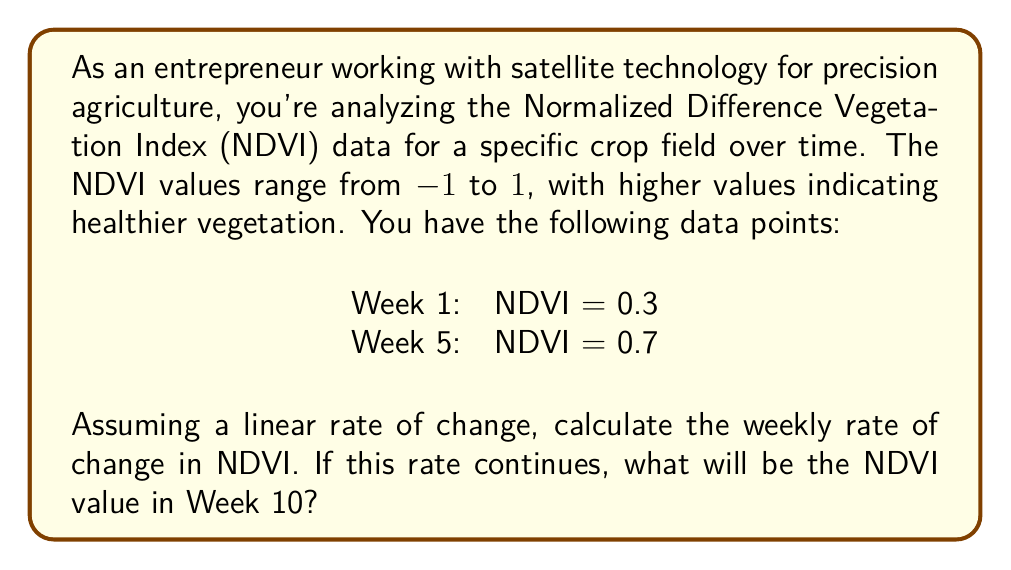Can you answer this question? To solve this problem, we'll follow these steps:

1. Calculate the rate of change in NDVI per week:
   Let's use the slope formula: $m = \frac{y_2 - y_1}{x_2 - x_1}$
   
   Where:
   $y_2$ is the NDVI value at Week 5 (0.7)
   $y_1$ is the NDVI value at Week 1 (0.3)
   $x_2$ is Week 5
   $x_1$ is Week 1

   $$m = \frac{0.7 - 0.3}{5 - 1} = \frac{0.4}{4} = 0.1$$

   So, the rate of change is 0.1 NDVI units per week.

2. To find the NDVI value in Week 10, we can use the point-slope form of a line:
   $y - y_1 = m(x - x_1)$

   Where:
   $y$ is the NDVI value we're looking for
   $y_1$ is the initial NDVI value (0.3)
   $m$ is the rate of change (0.1)
   $x$ is Week 10
   $x_1$ is Week 1

   $y - 0.3 = 0.1(10 - 1)$
   $y - 0.3 = 0.1(9)$
   $y - 0.3 = 0.9$
   $y = 1.2$

However, we need to consider that NDVI values are bounded between -1 and 1. Therefore, the actual NDVI value in Week 10 would be capped at 1.
Answer: The weekly rate of change in NDVI is 0.1 units per week. The NDVI value in Week 10 would be 1, as it's capped at the maximum possible NDVI value. 